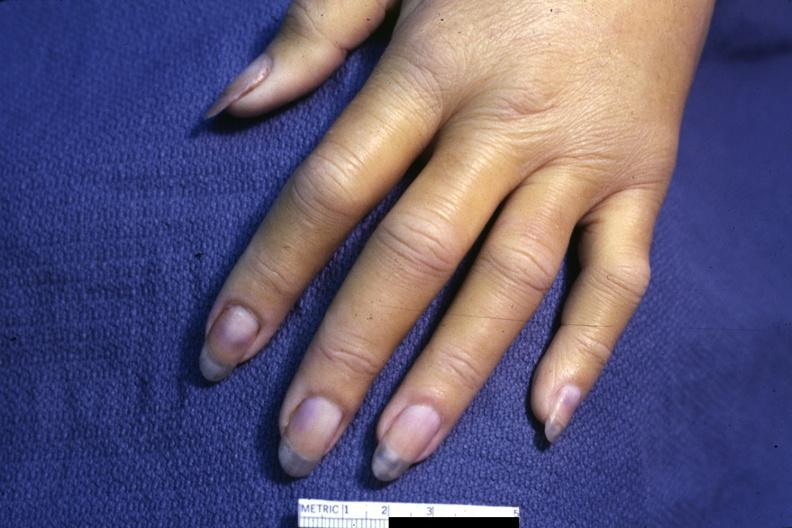what is present?
Answer the question using a single word or phrase. Acrocyanosis 